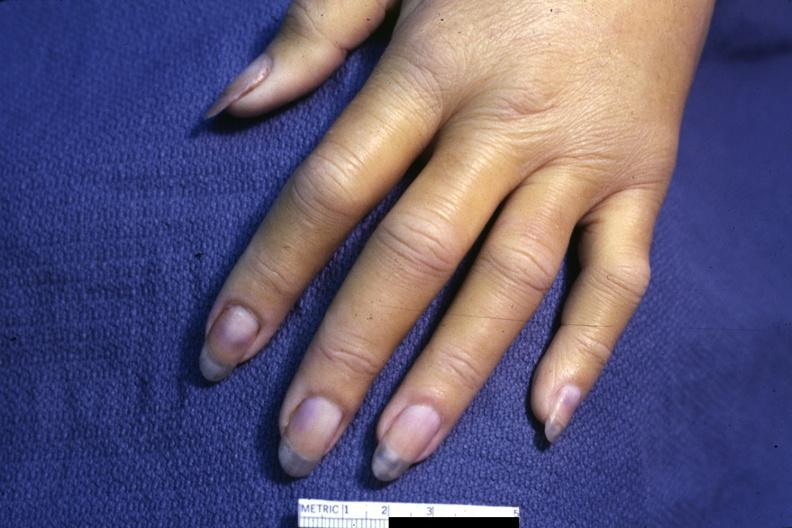what is present?
Answer the question using a single word or phrase. Acrocyanosis 